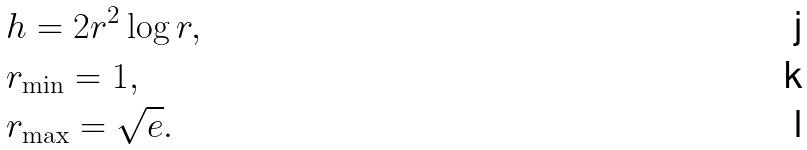Convert formula to latex. <formula><loc_0><loc_0><loc_500><loc_500>& h = 2 r ^ { 2 } \log r , \\ & r _ { \min } = 1 , \\ & r _ { \max } = \sqrt { e } .</formula> 